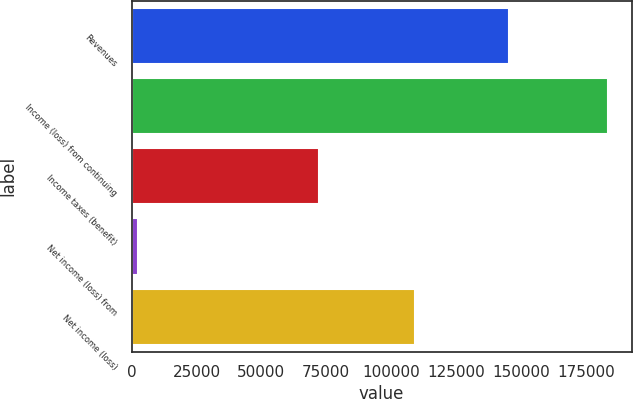Convert chart to OTSL. <chart><loc_0><loc_0><loc_500><loc_500><bar_chart><fcel>Revenues<fcel>Income (loss) from continuing<fcel>Income taxes (benefit)<fcel>Net income (loss) from<fcel>Net income (loss)<nl><fcel>145273<fcel>183516<fcel>72072<fcel>2395<fcel>109049<nl></chart> 